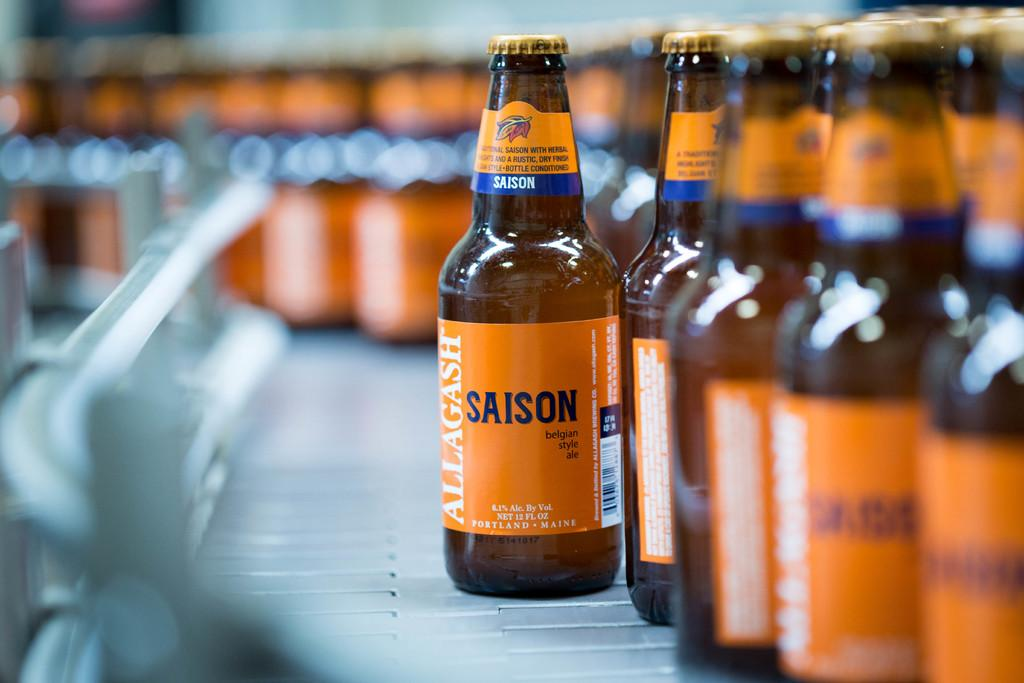<image>
Relay a brief, clear account of the picture shown. Orange bottles of Allagash Saison on top of a surface. 